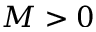Convert formula to latex. <formula><loc_0><loc_0><loc_500><loc_500>M > 0</formula> 